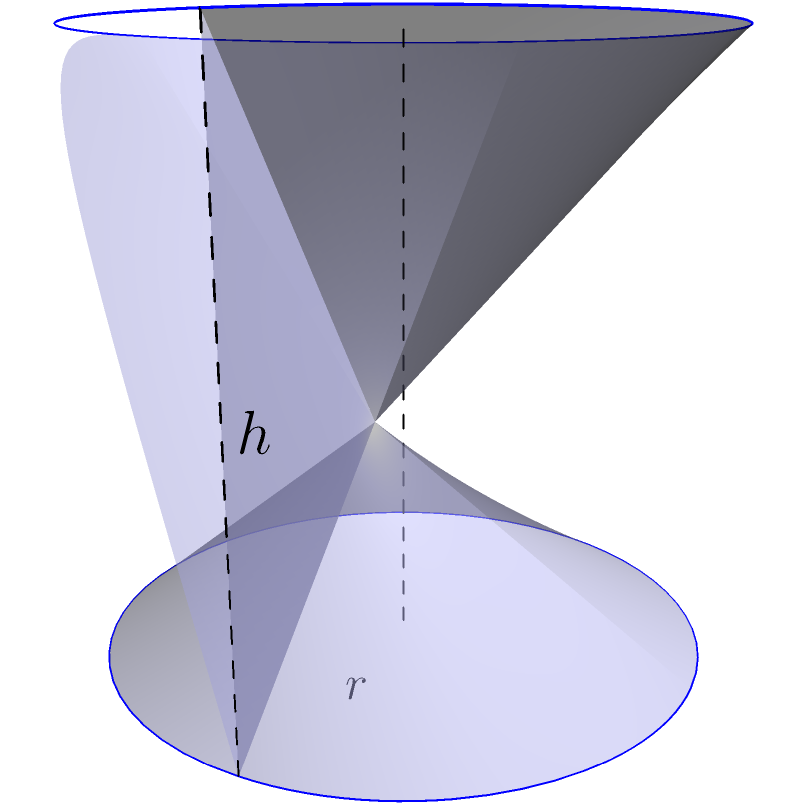As a ceramic artist working with exclusive materials, you want to create a cylindrical vase with a fixed surface area of 300 cm². What dimensions (radius and height) should you use to maximize the volume of the vase? Round your answer to the nearest 0.1 cm. Let's approach this step-by-step:

1) For a cylinder, we have:
   Surface Area: $S = 2\pi r^2 + 2\pi rh$
   Volume: $V = \pi r^2h$

2) Given: $S = 300$ cm²

3) We can express $h$ in terms of $r$:
   $300 = 2\pi r^2 + 2\pi rh$
   $h = \frac{300 - 2\pi r^2}{2\pi r}$

4) Substitute this into the volume formula:
   $V = \pi r^2 (\frac{300 - 2\pi r^2}{2\pi r})$
   $V = \frac{300r - 2\pi r^3}{2}$

5) To maximize volume, we differentiate $V$ with respect to $r$ and set it to zero:
   $\frac{dV}{dr} = \frac{300 - 6\pi r^2}{2} = 0$

6) Solve this equation:
   $300 - 6\pi r^2 = 0$
   $r^2 = \frac{50}{\pi}$
   $r = \sqrt{\frac{50}{\pi}} \approx 3.99$ cm

7) Now we can find $h$:
   $h = \frac{300 - 2\pi r^2}{2\pi r} = \frac{300 - 2\pi (\frac{50}{\pi})}{2\pi \sqrt{\frac{50}{\pi}}} = \sqrt{\frac{50}{\pi}} \approx 3.99$ cm

8) Rounding to the nearest 0.1 cm:
   $r \approx 4.0$ cm
   $h \approx 4.0$ cm
Answer: $r = 4.0$ cm, $h = 4.0$ cm 